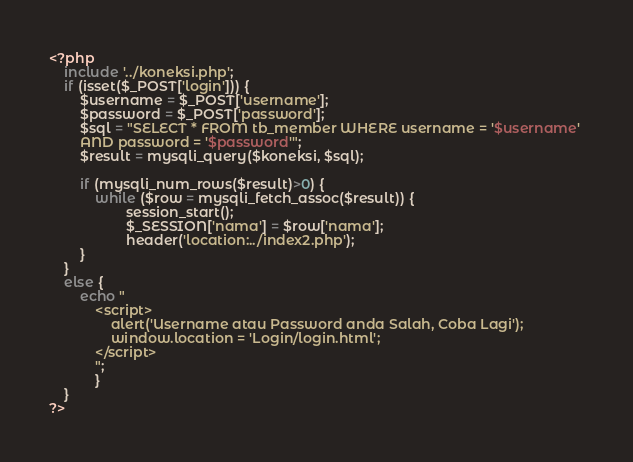Convert code to text. <code><loc_0><loc_0><loc_500><loc_500><_PHP_><?php 
    include '../koneksi.php';
    if (isset($_POST['login'])) {
        $username = $_POST['username'];
        $password = $_POST['password'];
        $sql = "SELECT * FROM tb_member WHERE username = '$username' 
        AND password = '$password'";
        $result = mysqli_query($koneksi, $sql);
        
        if (mysqli_num_rows($result)>0) {
            while ($row = mysqli_fetch_assoc($result)) {
                    session_start();
                    $_SESSION['nama'] = $row['nama'];
                    header('location:../index2.php');
        }
    }
    else {
        echo "
            <script>
                alert('Username atau Password anda Salah, Coba Lagi'); 
                window.location = 'Login/login.html';
            </script>
            ";
            }
    }
?></code> 